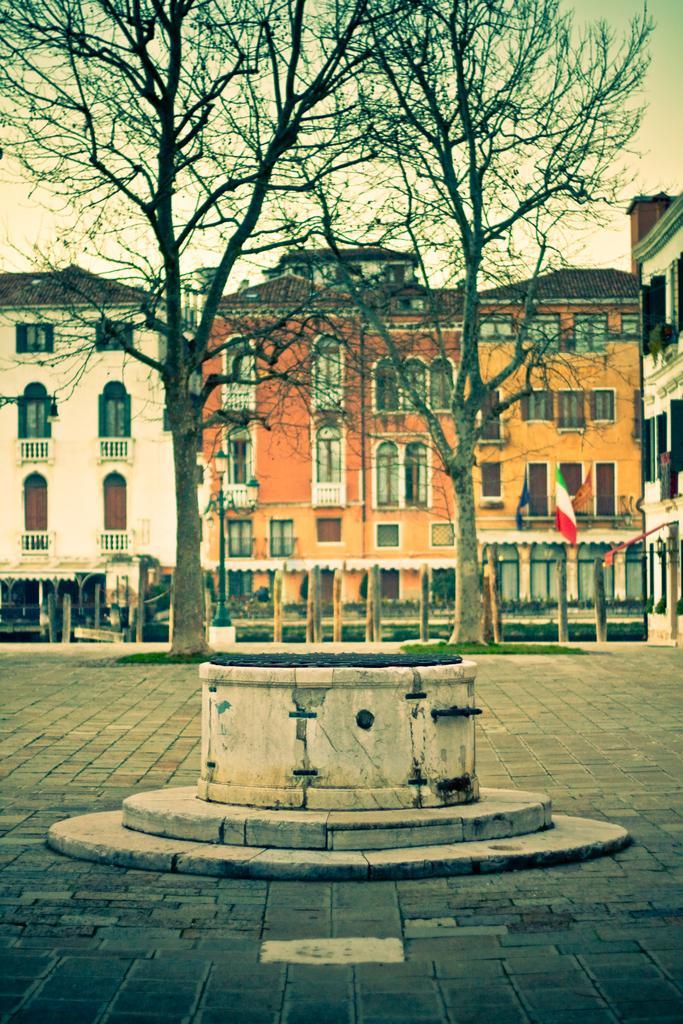Can you describe this image briefly? In this image we can see an object on the ground, there are trees, flag, sheds, buildings and the sky in the background. 